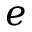<formula> <loc_0><loc_0><loc_500><loc_500>e</formula> 